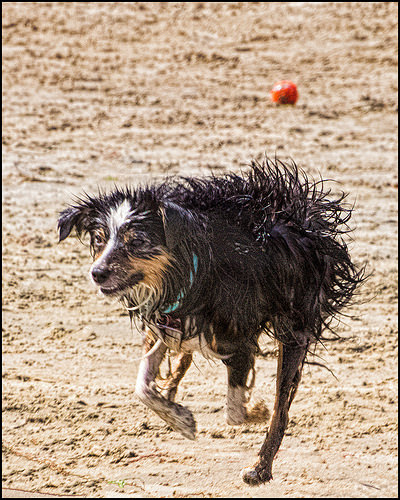<image>
Is the dog in the dirt? Yes. The dog is contained within or inside the dirt, showing a containment relationship. Is the dog next to the collar? No. The dog is not positioned next to the collar. They are located in different areas of the scene. Where is the dog in relation to the sand? Is it in front of the sand? No. The dog is not in front of the sand. The spatial positioning shows a different relationship between these objects. 